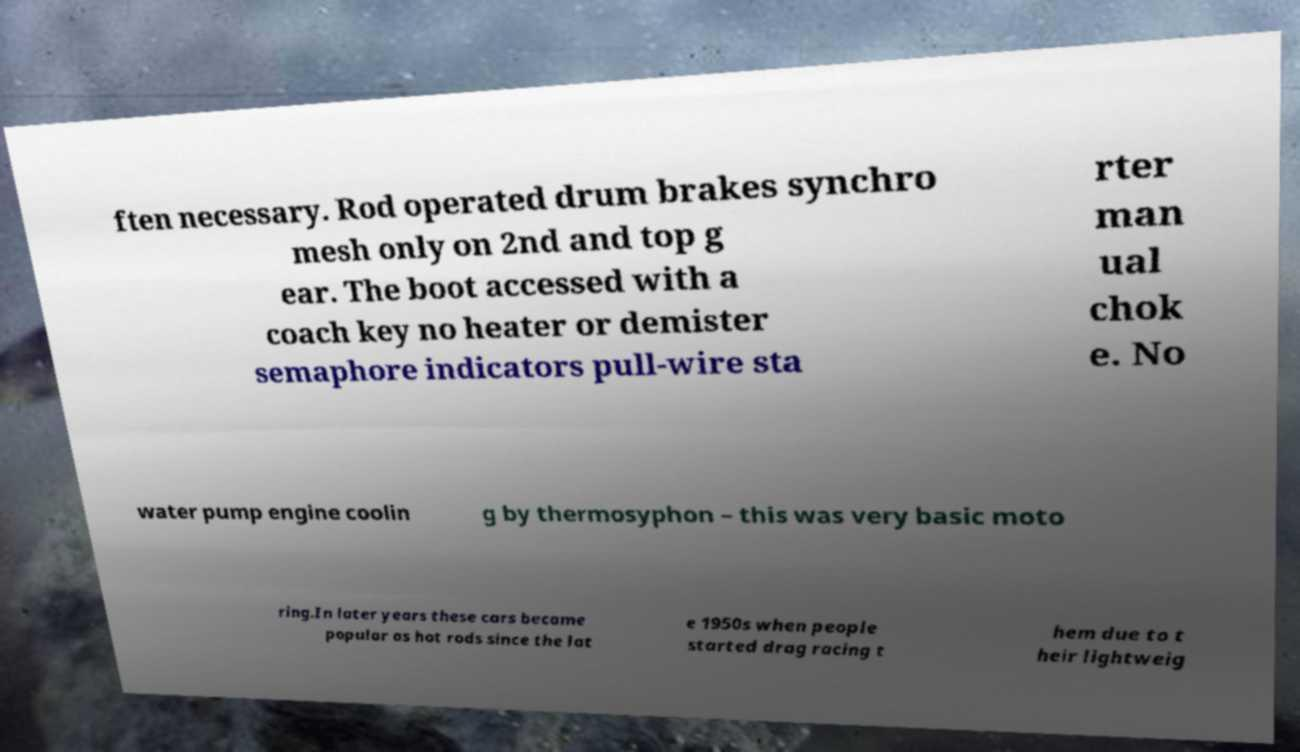Please read and relay the text visible in this image. What does it say? ften necessary. Rod operated drum brakes synchro mesh only on 2nd and top g ear. The boot accessed with a coach key no heater or demister semaphore indicators pull-wire sta rter man ual chok e. No water pump engine coolin g by thermosyphon – this was very basic moto ring.In later years these cars became popular as hot rods since the lat e 1950s when people started drag racing t hem due to t heir lightweig 